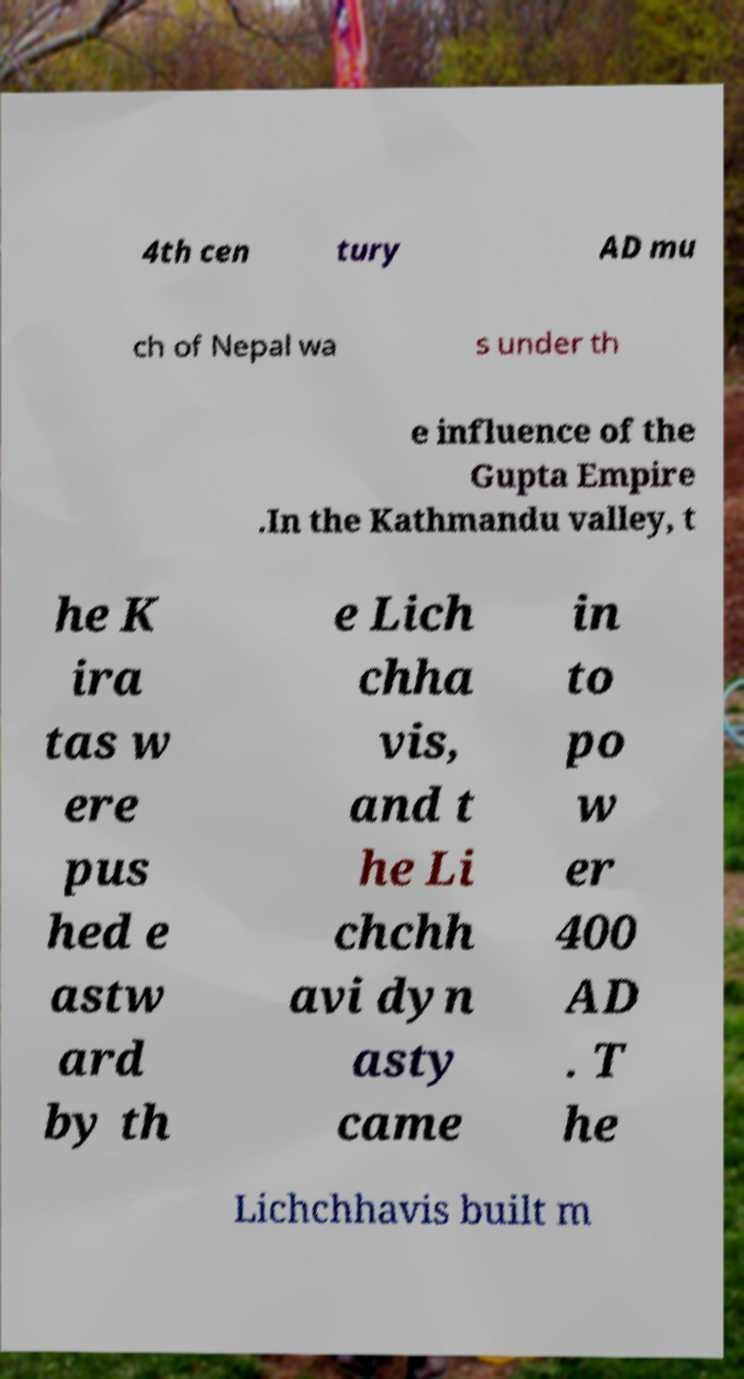Could you assist in decoding the text presented in this image and type it out clearly? 4th cen tury AD mu ch of Nepal wa s under th e influence of the Gupta Empire .In the Kathmandu valley, t he K ira tas w ere pus hed e astw ard by th e Lich chha vis, and t he Li chchh avi dyn asty came in to po w er 400 AD . T he Lichchhavis built m 